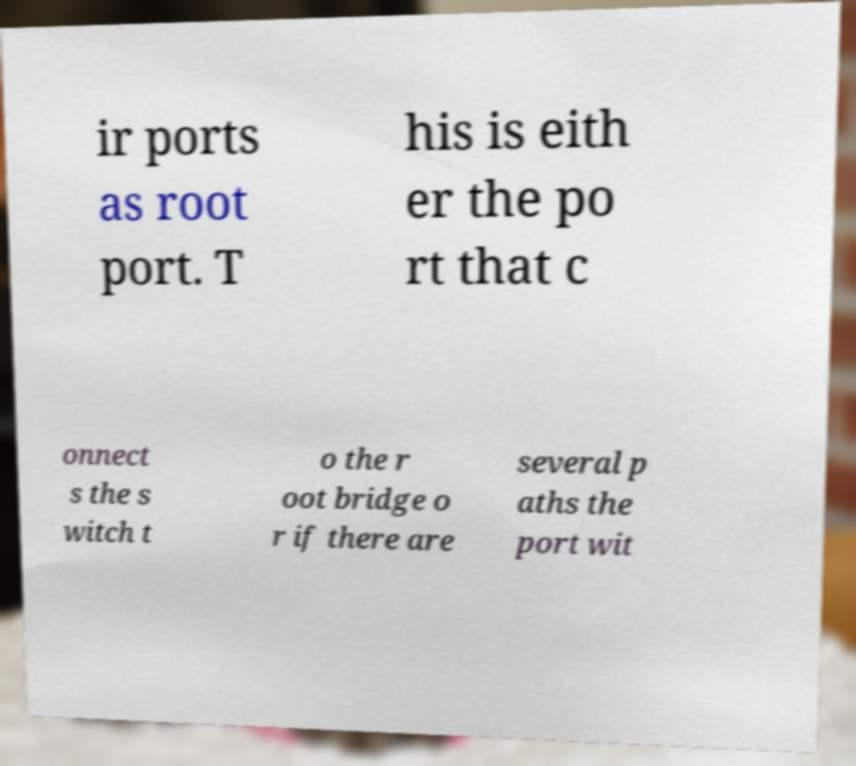Please identify and transcribe the text found in this image. ir ports as root port. T his is eith er the po rt that c onnect s the s witch t o the r oot bridge o r if there are several p aths the port wit 